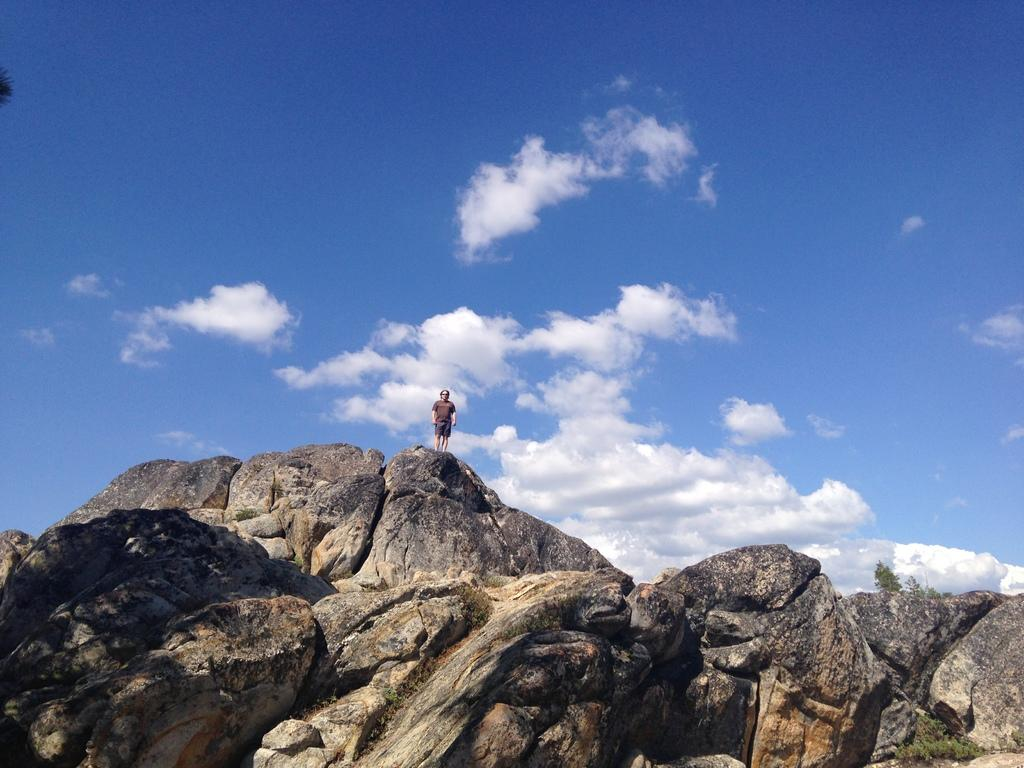What type of landscape can be seen in the image? There are hills in the image. Is there anyone present in the image? Yes, there is a person standing in the image. What can be seen above the hills in the image? The sky is visible in the image. What is the condition of the sky in the image? Clouds are present in the sky. What does the person taste in the image? There is no information about the person tasting anything in the image. What type of blood vessels can be seen in the image? There is no mention of blood vessels or any biological elements in the image. 